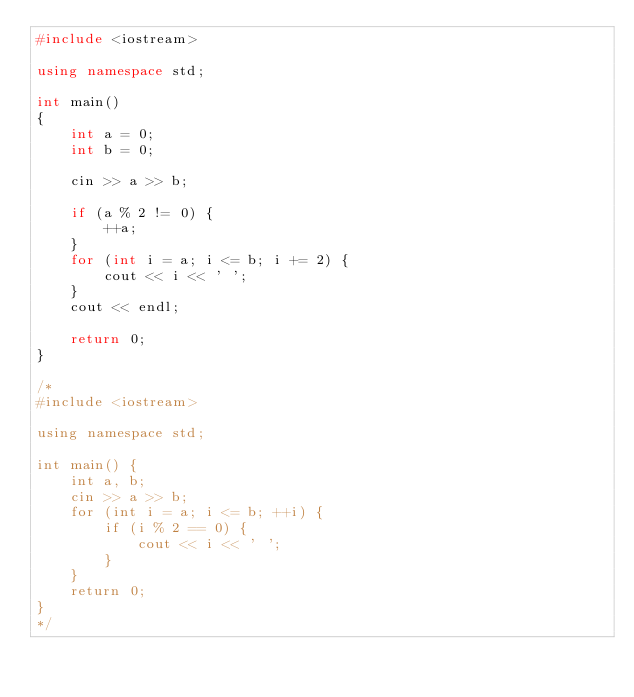Convert code to text. <code><loc_0><loc_0><loc_500><loc_500><_C++_>#include <iostream>

using namespace std;

int main()
{
    int a = 0;
    int b = 0;

    cin >> a >> b;

    if (a % 2 != 0) {
        ++a;
    }
    for (int i = a; i <= b; i += 2) {
        cout << i << ' ';
    }
    cout << endl;

    return 0;
}

/*
#include <iostream>

using namespace std;

int main() {
    int a, b;
    cin >> a >> b;
    for (int i = a; i <= b; ++i) {
        if (i % 2 == 0) {
            cout << i << ' ';
        }
    }
    return 0;
}
*/
</code> 